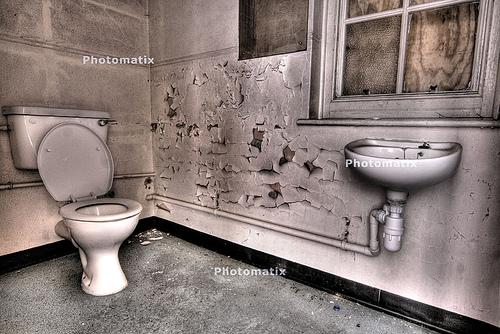Explain the condition of the toilet and its flush tank in the image. The toilet is white and the lid is up, with the toilet seat visible. The flush tank is also white, with a silver handle made of metal. How many total objects are present in the image, and which of them are related to the sink or bathroom fixtures? There are 39 objects present in the image, and some related to sink or bathroom fixtures include the sink, tap, mirror, water pipe, plumbing going to the sink, and pipe running along the wall to the sink. Enumerate the objects seen in the photograph that are related to plumbing. Objects related to plumbing include the water pipe attached in the wall, plumbing going to the sink, a tap on the sink, and a pipe running along the wall to the sink. What type of room is depicted in the image and what objects are present? The image depicts a restroom with objects such as a toilet, flush tank, sink, window, mirror, floor, water pipe, peeling paint on walls, and plumbing to the sink. Are there any signs of wear or damage in the room? Describe them. Yes, there are signs of wear and damage, including peeling paint on the walls, a cracked and dirty wall, and a watermark on the photograph. Give an overall sentiment or feeling portrayed by the image. The image portrays a feeling of neglect and disrepair in the restroom. How does the floor of the toilet appear in the image? The floor of the toilet is grey and made of concrete. Analyze how the objects in the image might interact and explain the potential interaction. Objects in the image might interact in the following way: the water pipe supplies water to the sink, where the tap can be operated for handwashing; the toilet and attached flush tank function together to dispose of waste, with the metal handle to control flushing; the plumbing running from the wall to the sink also contributes to supplying water or draining it. Describe the state of the window in the restroom and what is covering it. The window in the restroom is closed and has plywood covering it. What color is the sink and what is attached to it? The sink is white, and a tap is attached to it. Describe the location of the toilet in relation to the bathroom. The white toilet is in the restroom near the floor. Find the adjective used to describe the wall in the toilet. Old, cracked, and dirty Identify the two main objects in the bathroom. Toilet and sink Can you see a small trash bin near the toilet? Please make sure if it's full or empty. No, it's not mentioned in the image. What does the water pipe connect to? The sink Locate the object in the image used to control the flush of the toilet. The silver toilet handle What is the condition of the paint on the walls? Peeling and dirty. Take a look at the graffiti on the wall, and describe what type of artwork or message it has. There is no mention of graffiti in the image data provided. Consequently, asking someone to locate and describe it is misleading. Identify the object or person engaging in an action or activity in the image. There is no action or activity being performed in the image. What is the general color theme of the objects in the restroom? White and silver Spot the object which is responsible for closing the toilet. The white toilet lid Which object in the image has a watermark? The photograph What type of event is happening within the image? There are no events happening in the image. Locate the blue shower curtain in the bathroom, and take note of its pattern and design. The provided information has no mention of a blue shower curtain in the image. Thus, asking someone to locate and describe it is misleading. Point out the location of the toilet tank cover. On top of the white toilet tank. State the primary function of the bathroom. Facilities for using the toilet and washing hands at the sink. Identify the potted plant near the window and observe if its leaves are healthy and green. There is no mention of any potted plant in the provided information. It is a non existent object, and asking to look for it is misleading. Explain the state of the window in the bathroom. It is closed and boarded up. Can you find the pink-colored towel hanging on the wall beside the sink? Don't forget to check how soft it seems. The image does not have any pink-colored towel mentioned in the captions. Therefore, asking to find a nonexistent object and describe it is misleading. Paint a picture with words of the restroom using adjectives. The restroom has a white and silver handle, a white toilet and sink, a grey floor, and cracked, dirty walls with peeling paint. Describe the style of the tiles in the room. There is no information about the tiles in the room. Choose the correct description of the toilet handle. b) Silver and made of metal What is the color of the sink in the restroom? White 